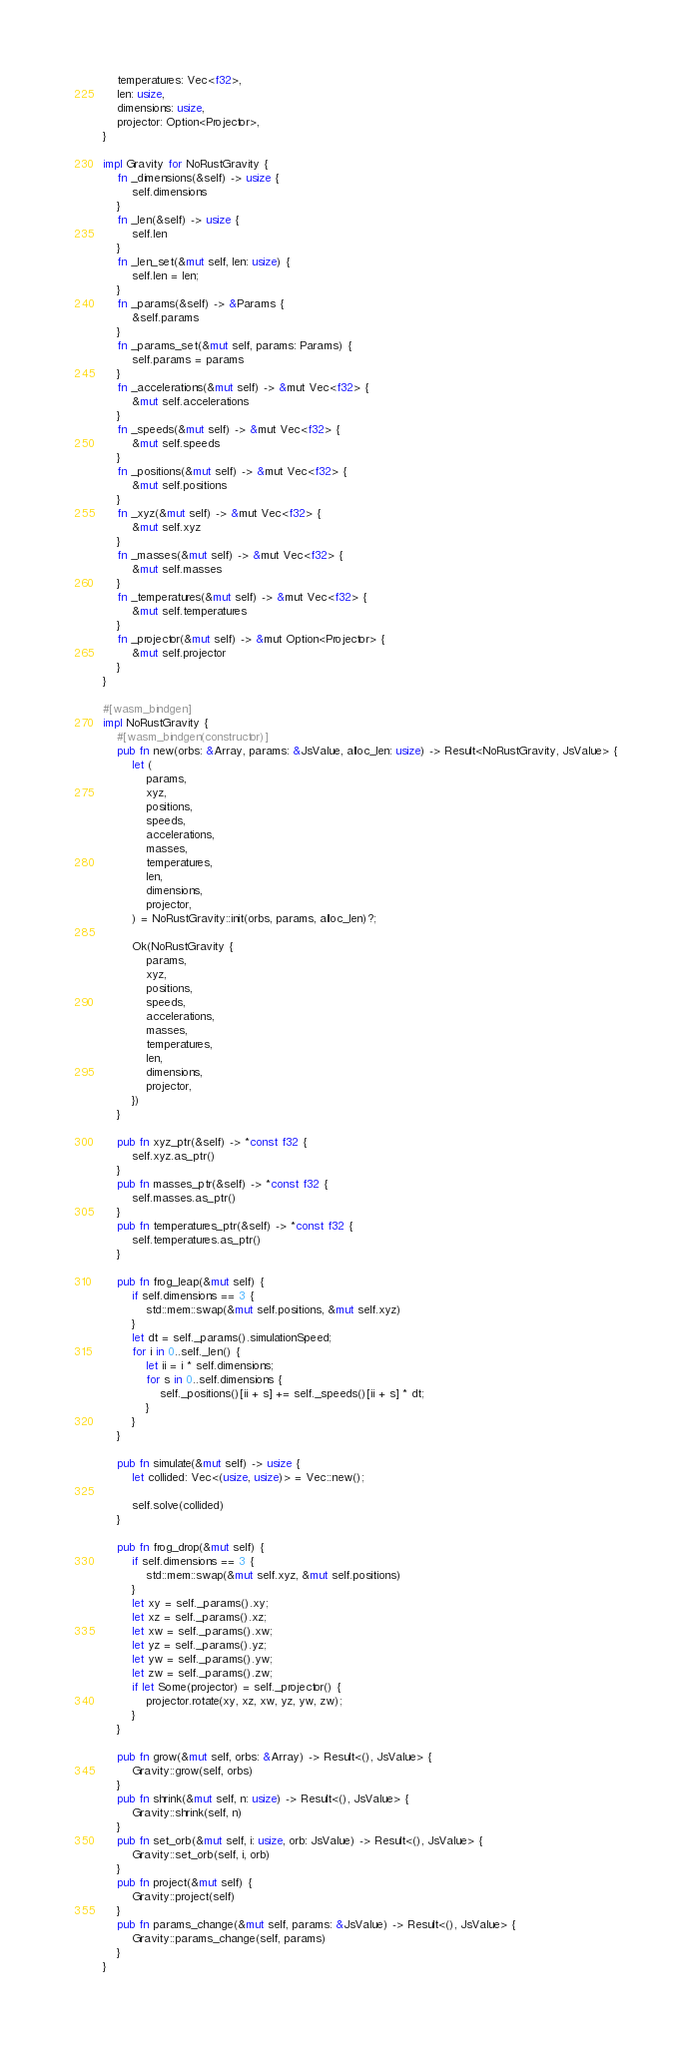<code> <loc_0><loc_0><loc_500><loc_500><_Rust_>    temperatures: Vec<f32>,
    len: usize,
    dimensions: usize,
    projector: Option<Projector>,
}

impl Gravity for NoRustGravity {
    fn _dimensions(&self) -> usize {
        self.dimensions
    }
    fn _len(&self) -> usize {
        self.len
    }
    fn _len_set(&mut self, len: usize) {
        self.len = len;
    }
    fn _params(&self) -> &Params {
        &self.params
    }
    fn _params_set(&mut self, params: Params) {
        self.params = params
    }
    fn _accelerations(&mut self) -> &mut Vec<f32> {
        &mut self.accelerations
    }
    fn _speeds(&mut self) -> &mut Vec<f32> {
        &mut self.speeds
    }
    fn _positions(&mut self) -> &mut Vec<f32> {
        &mut self.positions
    }
    fn _xyz(&mut self) -> &mut Vec<f32> {
        &mut self.xyz
    }
    fn _masses(&mut self) -> &mut Vec<f32> {
        &mut self.masses
    }
    fn _temperatures(&mut self) -> &mut Vec<f32> {
        &mut self.temperatures
    }
    fn _projector(&mut self) -> &mut Option<Projector> {
        &mut self.projector
    }
}

#[wasm_bindgen]
impl NoRustGravity {
    #[wasm_bindgen(constructor)]
    pub fn new(orbs: &Array, params: &JsValue, alloc_len: usize) -> Result<NoRustGravity, JsValue> {
        let (
            params,
            xyz,
            positions,
            speeds,
            accelerations,
            masses,
            temperatures,
            len,
            dimensions,
            projector,
        ) = NoRustGravity::init(orbs, params, alloc_len)?;

        Ok(NoRustGravity {
            params,
            xyz,
            positions,
            speeds,
            accelerations,
            masses,
            temperatures,
            len,
            dimensions,
            projector,
        })
    }

    pub fn xyz_ptr(&self) -> *const f32 {
        self.xyz.as_ptr()
    }
    pub fn masses_ptr(&self) -> *const f32 {
        self.masses.as_ptr()
    }
    pub fn temperatures_ptr(&self) -> *const f32 {
        self.temperatures.as_ptr()
    }

    pub fn frog_leap(&mut self) {
        if self.dimensions == 3 {
            std::mem::swap(&mut self.positions, &mut self.xyz)
        }
        let dt = self._params().simulationSpeed;
        for i in 0..self._len() {
            let ii = i * self.dimensions;
            for s in 0..self.dimensions {
                self._positions()[ii + s] += self._speeds()[ii + s] * dt;
            }
        }
    }

    pub fn simulate(&mut self) -> usize {
        let collided: Vec<(usize, usize)> = Vec::new();

        self.solve(collided)
    }

    pub fn frog_drop(&mut self) {
        if self.dimensions == 3 {
            std::mem::swap(&mut self.xyz, &mut self.positions)
        }
        let xy = self._params().xy;
        let xz = self._params().xz;
        let xw = self._params().xw;
        let yz = self._params().yz;
        let yw = self._params().yw;
        let zw = self._params().zw;
        if let Some(projector) = self._projector() {
            projector.rotate(xy, xz, xw, yz, yw, zw);
        }
    }

    pub fn grow(&mut self, orbs: &Array) -> Result<(), JsValue> {
        Gravity::grow(self, orbs)
    }
    pub fn shrink(&mut self, n: usize) -> Result<(), JsValue> {
        Gravity::shrink(self, n)
    }
    pub fn set_orb(&mut self, i: usize, orb: JsValue) -> Result<(), JsValue> {
        Gravity::set_orb(self, i, orb)
    }
    pub fn project(&mut self) {
        Gravity::project(self)
    }
    pub fn params_change(&mut self, params: &JsValue) -> Result<(), JsValue> {
        Gravity::params_change(self, params)
    }
}
</code> 